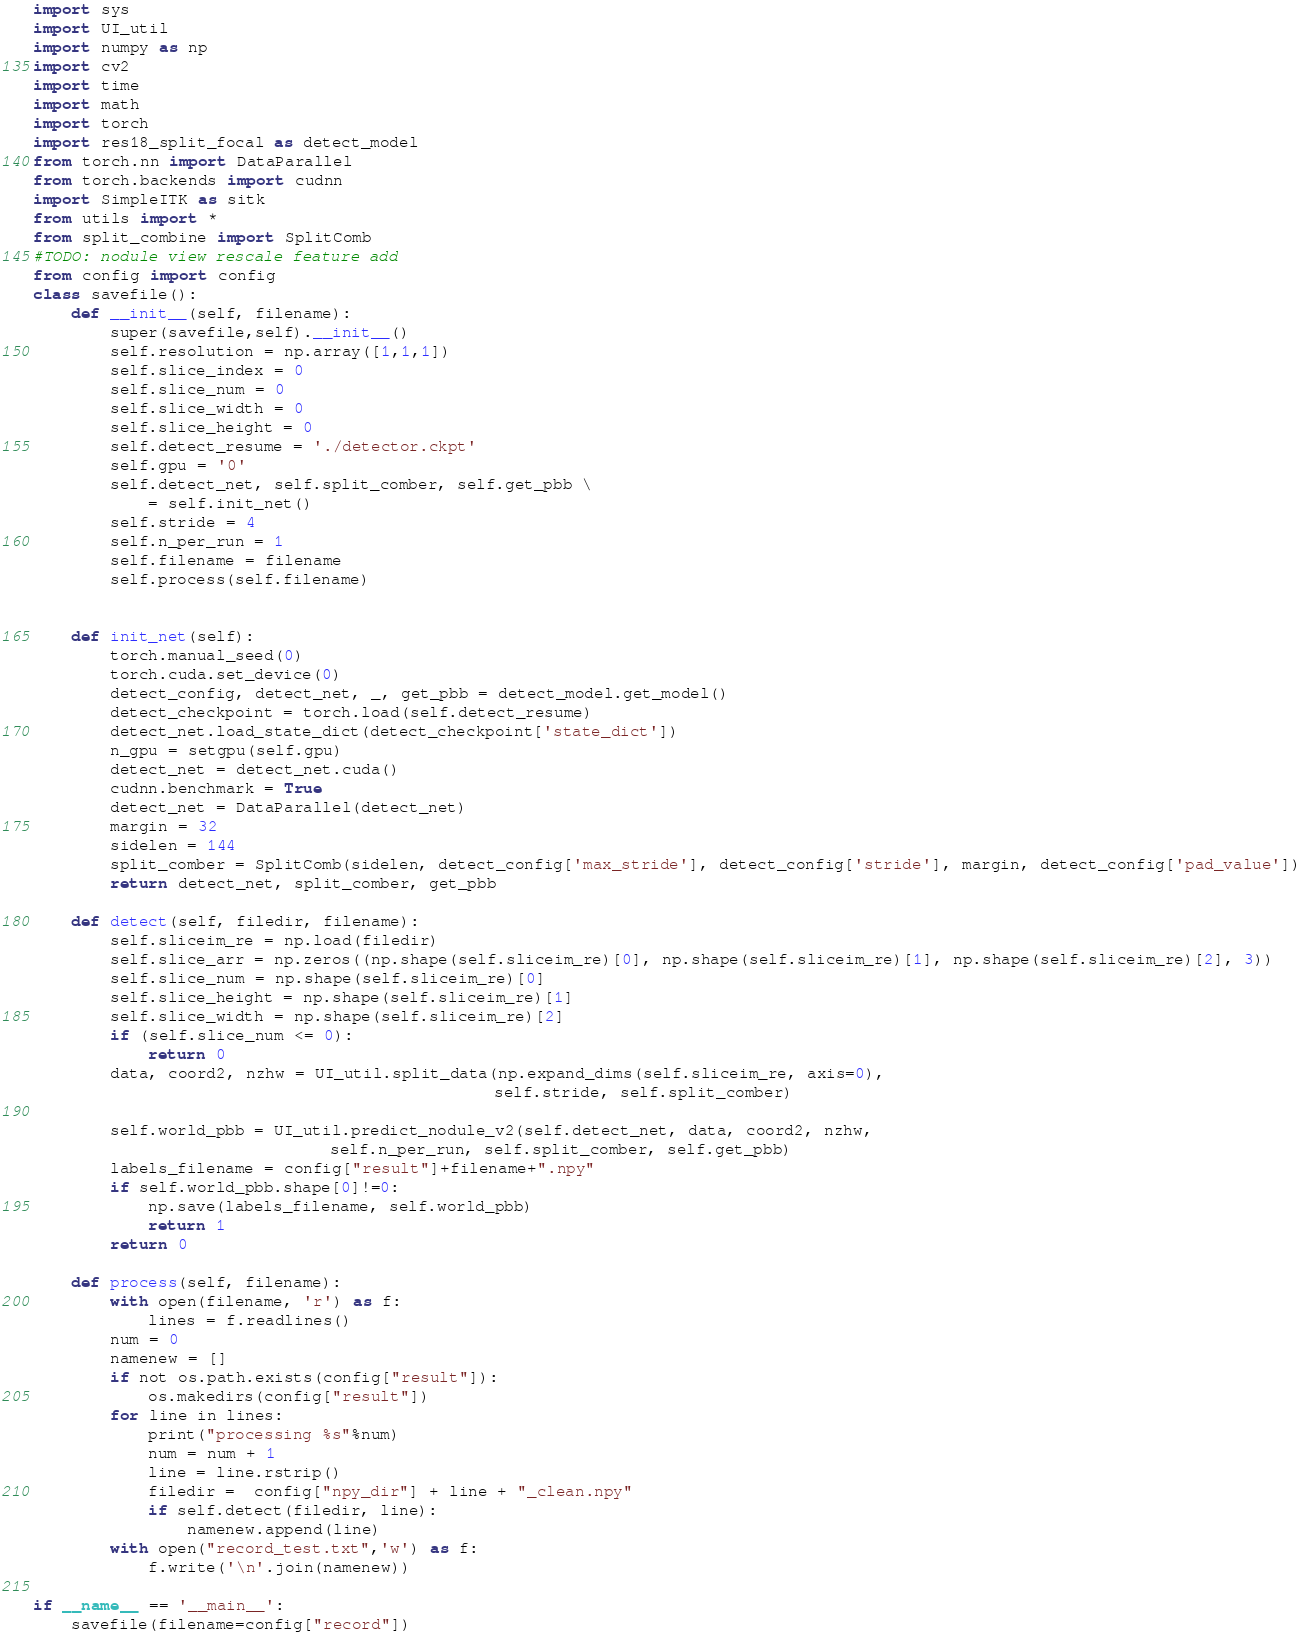Convert code to text. <code><loc_0><loc_0><loc_500><loc_500><_Python_>import sys
import UI_util
import numpy as np
import cv2
import time
import math
import torch
import res18_split_focal as detect_model
from torch.nn import DataParallel
from torch.backends import cudnn
import SimpleITK as sitk
from utils import *
from split_combine import SplitComb
#TODO: nodule view rescale feature add
from config import config
class savefile():
    def __init__(self, filename):
        super(savefile,self).__init__()
        self.resolution = np.array([1,1,1])
        self.slice_index = 0
        self.slice_num = 0
        self.slice_width = 0
        self.slice_height = 0
        self.detect_resume = './detector.ckpt'
        self.gpu = '0'
        self.detect_net, self.split_comber, self.get_pbb \
            = self.init_net()
        self.stride = 4
        self.n_per_run = 1
        self.filename = filename
        self.process(self.filename)


    def init_net(self):
        torch.manual_seed(0)
        torch.cuda.set_device(0)
        detect_config, detect_net, _, get_pbb = detect_model.get_model()
        detect_checkpoint = torch.load(self.detect_resume)
        detect_net.load_state_dict(detect_checkpoint['state_dict'])
        n_gpu = setgpu(self.gpu)
        detect_net = detect_net.cuda()
        cudnn.benchmark = True
        detect_net = DataParallel(detect_net)
        margin = 32
        sidelen = 144
        split_comber = SplitComb(sidelen, detect_config['max_stride'], detect_config['stride'], margin, detect_config['pad_value'])
        return detect_net, split_comber, get_pbb

    def detect(self, filedir, filename):
        self.sliceim_re = np.load(filedir)
        self.slice_arr = np.zeros((np.shape(self.sliceim_re)[0], np.shape(self.sliceim_re)[1], np.shape(self.sliceim_re)[2], 3))
        self.slice_num = np.shape(self.sliceim_re)[0]
        self.slice_height = np.shape(self.sliceim_re)[1]
        self.slice_width = np.shape(self.sliceim_re)[2]
        if (self.slice_num <= 0):
            return 0
        data, coord2, nzhw = UI_util.split_data(np.expand_dims(self.sliceim_re, axis=0),
                                                self.stride, self.split_comber)

        self.world_pbb = UI_util.predict_nodule_v2(self.detect_net, data, coord2, nzhw,
                               self.n_per_run, self.split_comber, self.get_pbb)
        labels_filename = config["result"]+filename+".npy"
        if self.world_pbb.shape[0]!=0:
            np.save(labels_filename, self.world_pbb)
            return 1
        return 0

    def process(self, filename):
        with open(filename, 'r') as f:
            lines = f.readlines()
        num = 0
        namenew = []
        if not os.path.exists(config["result"]):
            os.makedirs(config["result"])
        for line in lines:
            print("processing %s"%num)
            num = num + 1
            line = line.rstrip()
            filedir =  config["npy_dir"] + line + "_clean.npy"
            if self.detect(filedir, line):
                namenew.append(line)
        with open("record_test.txt",'w') as f:
            f.write('\n'.join(namenew))

if __name__ == '__main__':
    savefile(filename=config["record"])
</code> 